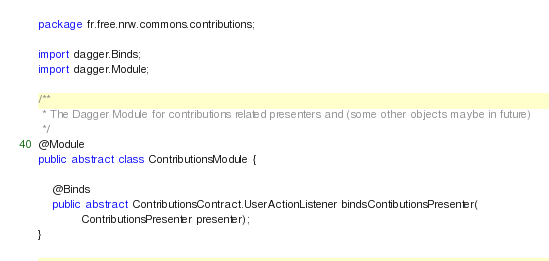<code> <loc_0><loc_0><loc_500><loc_500><_Java_>package fr.free.nrw.commons.contributions;

import dagger.Binds;
import dagger.Module;

/**
 * The Dagger Module for contributions related presenters and (some other objects maybe in future)
 */
@Module
public abstract class ContributionsModule {

    @Binds
    public abstract ContributionsContract.UserActionListener bindsContibutionsPresenter(
            ContributionsPresenter presenter);
}
</code> 